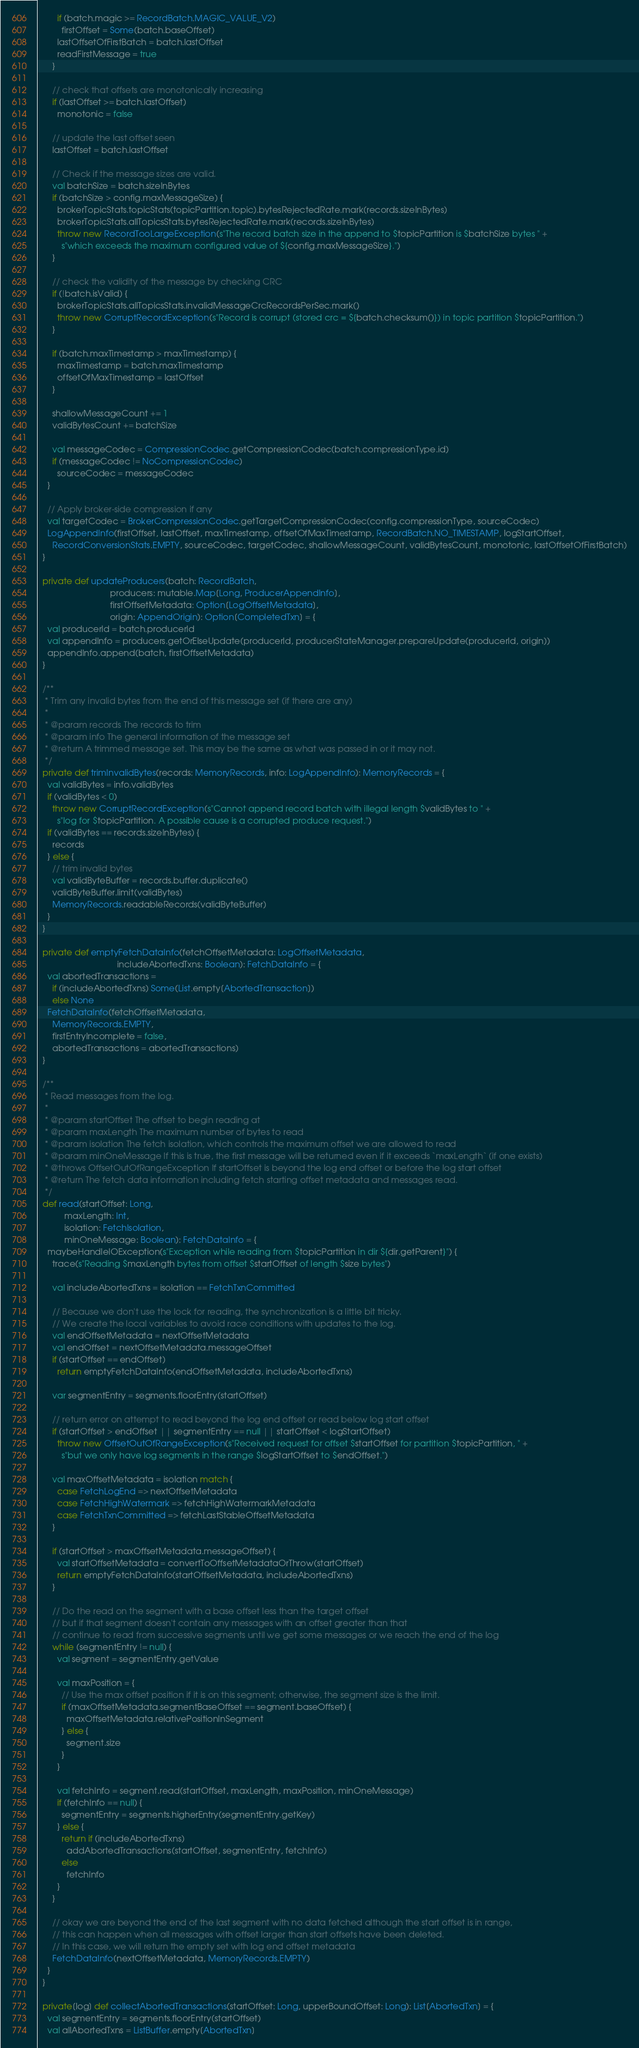Convert code to text. <code><loc_0><loc_0><loc_500><loc_500><_Scala_>        if (batch.magic >= RecordBatch.MAGIC_VALUE_V2)
          firstOffset = Some(batch.baseOffset)
        lastOffsetOfFirstBatch = batch.lastOffset
        readFirstMessage = true
      }

      // check that offsets are monotonically increasing
      if (lastOffset >= batch.lastOffset)
        monotonic = false

      // update the last offset seen
      lastOffset = batch.lastOffset

      // Check if the message sizes are valid.
      val batchSize = batch.sizeInBytes
      if (batchSize > config.maxMessageSize) {
        brokerTopicStats.topicStats(topicPartition.topic).bytesRejectedRate.mark(records.sizeInBytes)
        brokerTopicStats.allTopicsStats.bytesRejectedRate.mark(records.sizeInBytes)
        throw new RecordTooLargeException(s"The record batch size in the append to $topicPartition is $batchSize bytes " +
          s"which exceeds the maximum configured value of ${config.maxMessageSize}.")
      }

      // check the validity of the message by checking CRC
      if (!batch.isValid) {
        brokerTopicStats.allTopicsStats.invalidMessageCrcRecordsPerSec.mark()
        throw new CorruptRecordException(s"Record is corrupt (stored crc = ${batch.checksum()}) in topic partition $topicPartition.")
      }

      if (batch.maxTimestamp > maxTimestamp) {
        maxTimestamp = batch.maxTimestamp
        offsetOfMaxTimestamp = lastOffset
      }

      shallowMessageCount += 1
      validBytesCount += batchSize

      val messageCodec = CompressionCodec.getCompressionCodec(batch.compressionType.id)
      if (messageCodec != NoCompressionCodec)
        sourceCodec = messageCodec
    }

    // Apply broker-side compression if any
    val targetCodec = BrokerCompressionCodec.getTargetCompressionCodec(config.compressionType, sourceCodec)
    LogAppendInfo(firstOffset, lastOffset, maxTimestamp, offsetOfMaxTimestamp, RecordBatch.NO_TIMESTAMP, logStartOffset,
      RecordConversionStats.EMPTY, sourceCodec, targetCodec, shallowMessageCount, validBytesCount, monotonic, lastOffsetOfFirstBatch)
  }

  private def updateProducers(batch: RecordBatch,
                              producers: mutable.Map[Long, ProducerAppendInfo],
                              firstOffsetMetadata: Option[LogOffsetMetadata],
                              origin: AppendOrigin): Option[CompletedTxn] = {
    val producerId = batch.producerId
    val appendInfo = producers.getOrElseUpdate(producerId, producerStateManager.prepareUpdate(producerId, origin))
    appendInfo.append(batch, firstOffsetMetadata)
  }

  /**
   * Trim any invalid bytes from the end of this message set (if there are any)
   *
   * @param records The records to trim
   * @param info The general information of the message set
   * @return A trimmed message set. This may be the same as what was passed in or it may not.
   */
  private def trimInvalidBytes(records: MemoryRecords, info: LogAppendInfo): MemoryRecords = {
    val validBytes = info.validBytes
    if (validBytes < 0)
      throw new CorruptRecordException(s"Cannot append record batch with illegal length $validBytes to " +
        s"log for $topicPartition. A possible cause is a corrupted produce request.")
    if (validBytes == records.sizeInBytes) {
      records
    } else {
      // trim invalid bytes
      val validByteBuffer = records.buffer.duplicate()
      validByteBuffer.limit(validBytes)
      MemoryRecords.readableRecords(validByteBuffer)
    }
  }

  private def emptyFetchDataInfo(fetchOffsetMetadata: LogOffsetMetadata,
                                 includeAbortedTxns: Boolean): FetchDataInfo = {
    val abortedTransactions =
      if (includeAbortedTxns) Some(List.empty[AbortedTransaction])
      else None
    FetchDataInfo(fetchOffsetMetadata,
      MemoryRecords.EMPTY,
      firstEntryIncomplete = false,
      abortedTransactions = abortedTransactions)
  }

  /**
   * Read messages from the log.
   *
   * @param startOffset The offset to begin reading at
   * @param maxLength The maximum number of bytes to read
   * @param isolation The fetch isolation, which controls the maximum offset we are allowed to read
   * @param minOneMessage If this is true, the first message will be returned even if it exceeds `maxLength` (if one exists)
   * @throws OffsetOutOfRangeException If startOffset is beyond the log end offset or before the log start offset
   * @return The fetch data information including fetch starting offset metadata and messages read.
   */
  def read(startOffset: Long,
           maxLength: Int,
           isolation: FetchIsolation,
           minOneMessage: Boolean): FetchDataInfo = {
    maybeHandleIOException(s"Exception while reading from $topicPartition in dir ${dir.getParent}") {
      trace(s"Reading $maxLength bytes from offset $startOffset of length $size bytes")

      val includeAbortedTxns = isolation == FetchTxnCommitted

      // Because we don't use the lock for reading, the synchronization is a little bit tricky.
      // We create the local variables to avoid race conditions with updates to the log.
      val endOffsetMetadata = nextOffsetMetadata
      val endOffset = nextOffsetMetadata.messageOffset
      if (startOffset == endOffset)
        return emptyFetchDataInfo(endOffsetMetadata, includeAbortedTxns)

      var segmentEntry = segments.floorEntry(startOffset)

      // return error on attempt to read beyond the log end offset or read below log start offset
      if (startOffset > endOffset || segmentEntry == null || startOffset < logStartOffset)
        throw new OffsetOutOfRangeException(s"Received request for offset $startOffset for partition $topicPartition, " +
          s"but we only have log segments in the range $logStartOffset to $endOffset.")

      val maxOffsetMetadata = isolation match {
        case FetchLogEnd => nextOffsetMetadata
        case FetchHighWatermark => fetchHighWatermarkMetadata
        case FetchTxnCommitted => fetchLastStableOffsetMetadata
      }

      if (startOffset > maxOffsetMetadata.messageOffset) {
        val startOffsetMetadata = convertToOffsetMetadataOrThrow(startOffset)
        return emptyFetchDataInfo(startOffsetMetadata, includeAbortedTxns)
      }

      // Do the read on the segment with a base offset less than the target offset
      // but if that segment doesn't contain any messages with an offset greater than that
      // continue to read from successive segments until we get some messages or we reach the end of the log
      while (segmentEntry != null) {
        val segment = segmentEntry.getValue

        val maxPosition = {
          // Use the max offset position if it is on this segment; otherwise, the segment size is the limit.
          if (maxOffsetMetadata.segmentBaseOffset == segment.baseOffset) {
            maxOffsetMetadata.relativePositionInSegment
          } else {
            segment.size
          }
        }

        val fetchInfo = segment.read(startOffset, maxLength, maxPosition, minOneMessage)
        if (fetchInfo == null) {
          segmentEntry = segments.higherEntry(segmentEntry.getKey)
        } else {
          return if (includeAbortedTxns)
            addAbortedTransactions(startOffset, segmentEntry, fetchInfo)
          else
            fetchInfo
        }
      }

      // okay we are beyond the end of the last segment with no data fetched although the start offset is in range,
      // this can happen when all messages with offset larger than start offsets have been deleted.
      // In this case, we will return the empty set with log end offset metadata
      FetchDataInfo(nextOffsetMetadata, MemoryRecords.EMPTY)
    }
  }

  private[log] def collectAbortedTransactions(startOffset: Long, upperBoundOffset: Long): List[AbortedTxn] = {
    val segmentEntry = segments.floorEntry(startOffset)
    val allAbortedTxns = ListBuffer.empty[AbortedTxn]</code> 